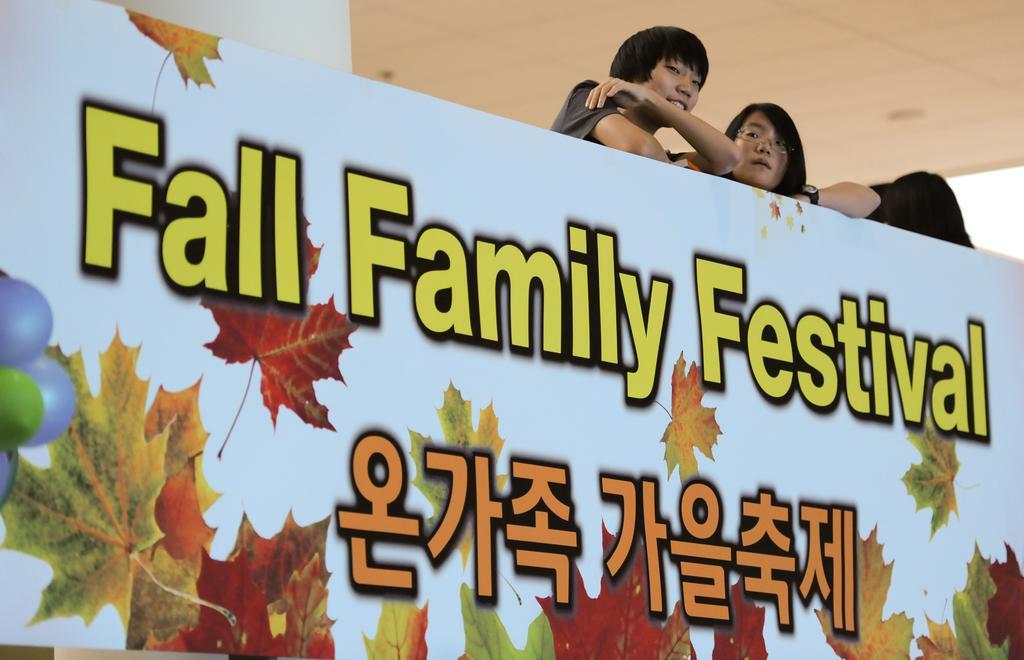Please provide a concise description of this image. In this image we can see a wall with some text written on it and there are two people standing behind the wall. 